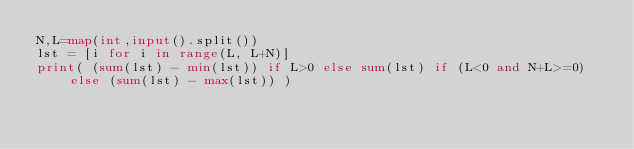Convert code to text. <code><loc_0><loc_0><loc_500><loc_500><_Python_>N,L=map(int,input().split())
lst = [i for i in range(L, L+N)]
print( (sum(lst) - min(lst)) if L>0 else sum(lst) if (L<0 and N+L>=0) else (sum(lst) - max(lst)) )</code> 